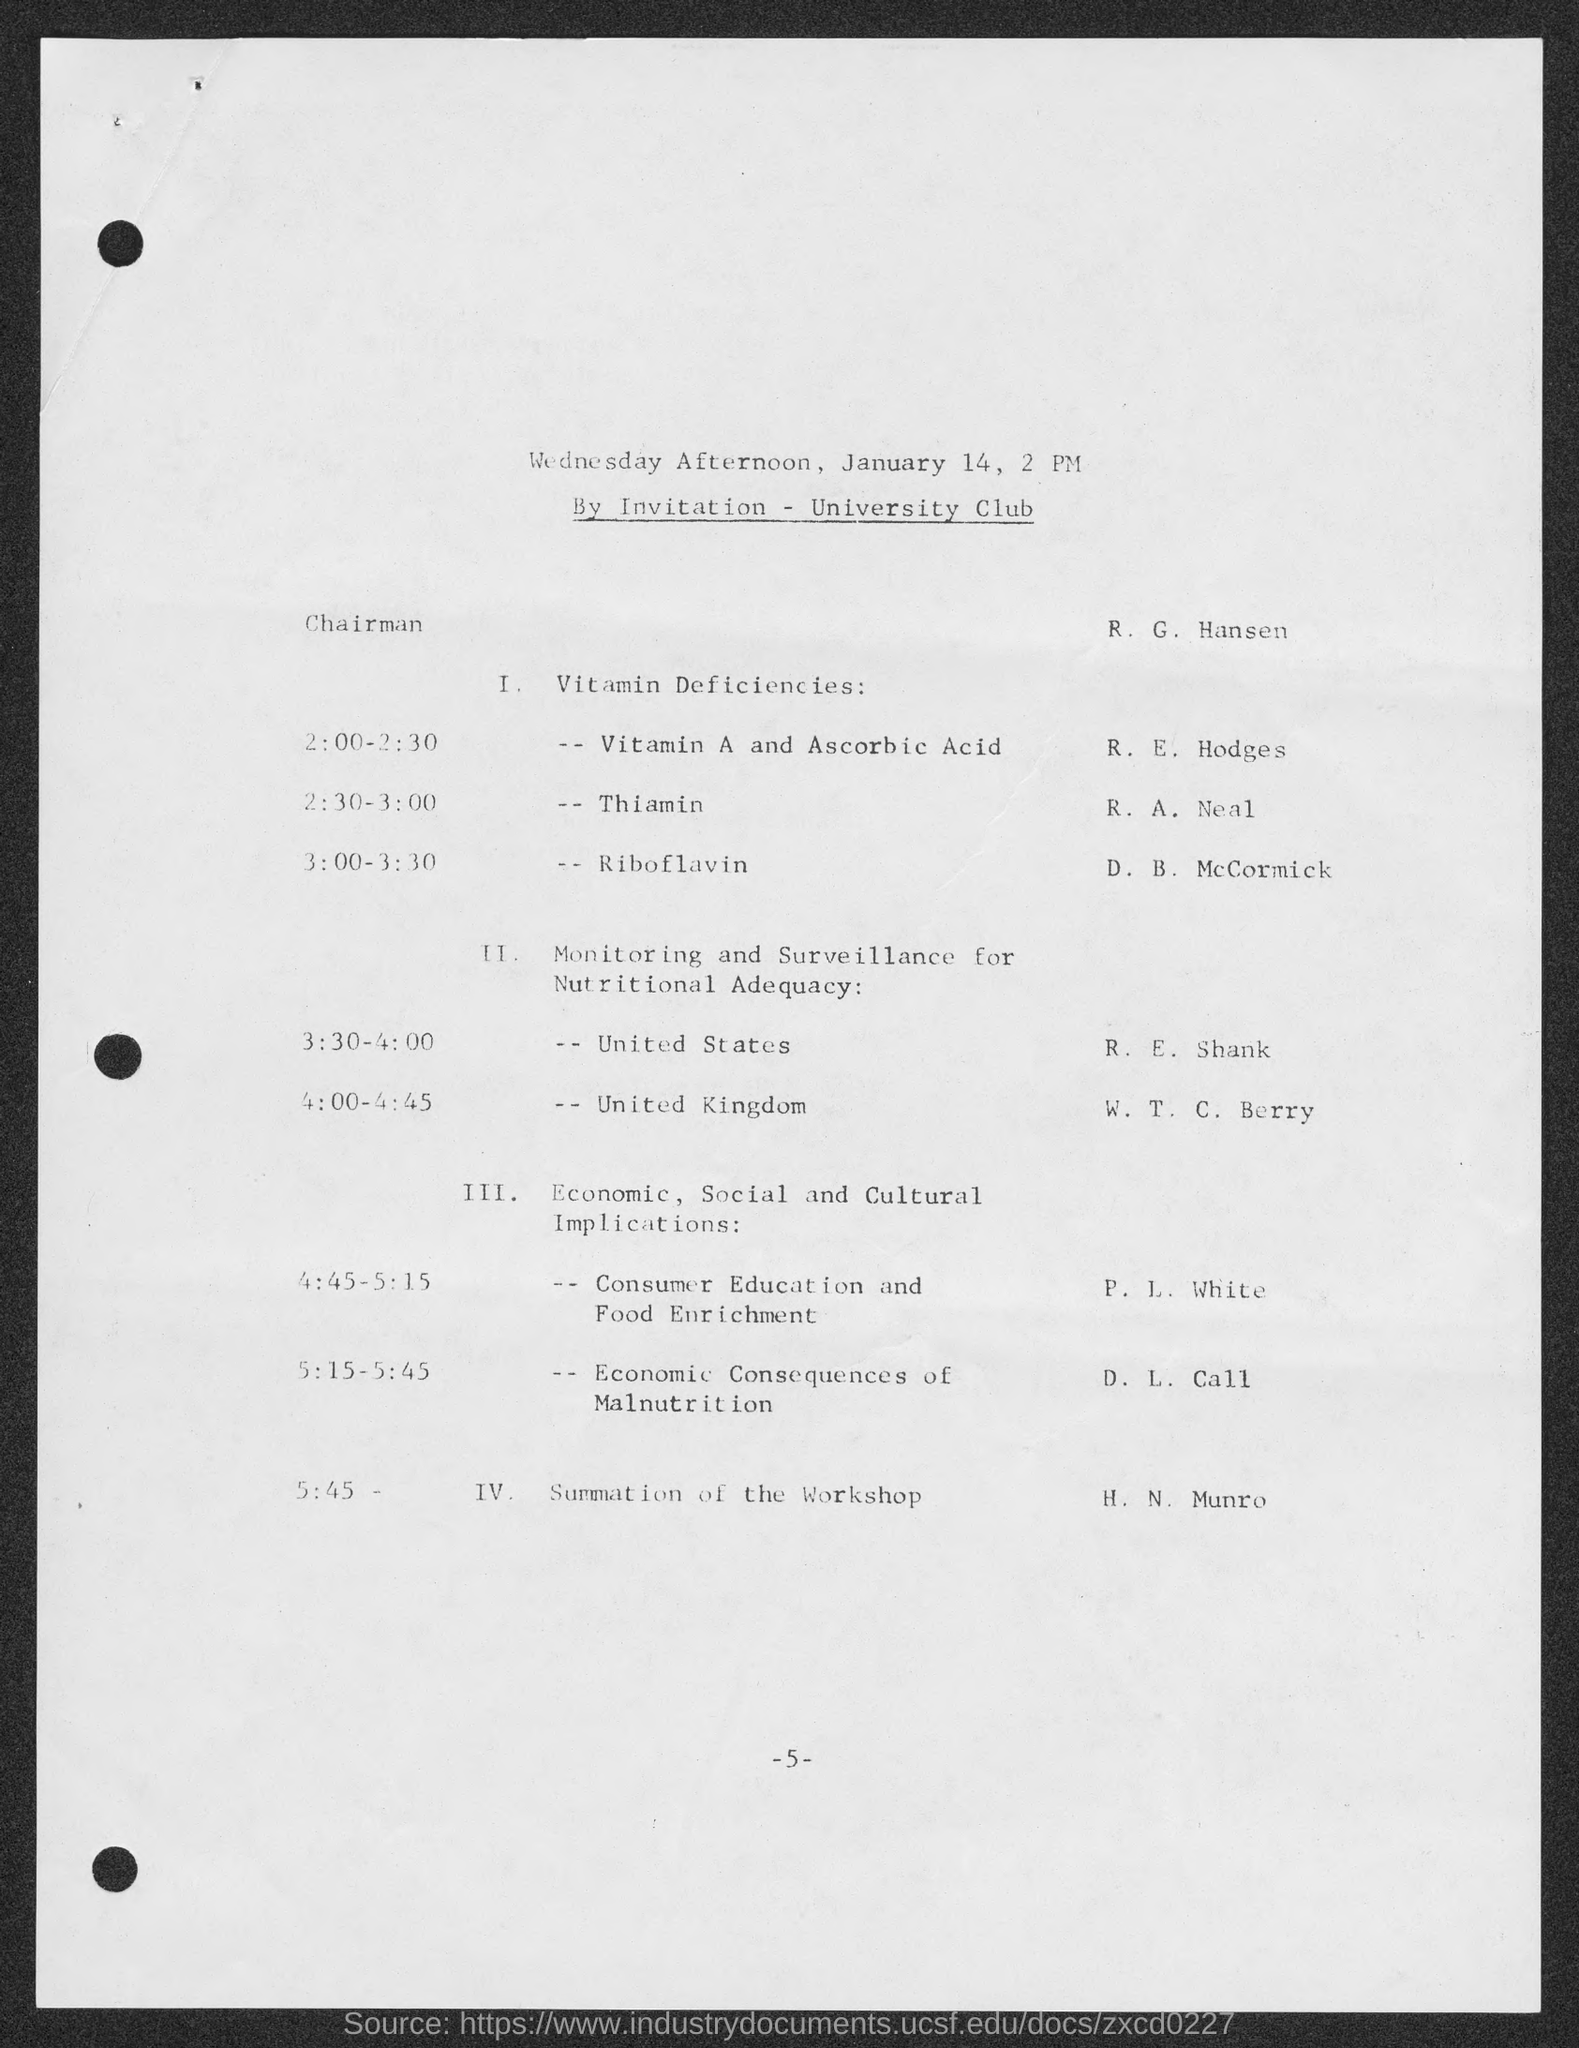What is the number at bottom of the page?
Provide a short and direct response. -5-. 